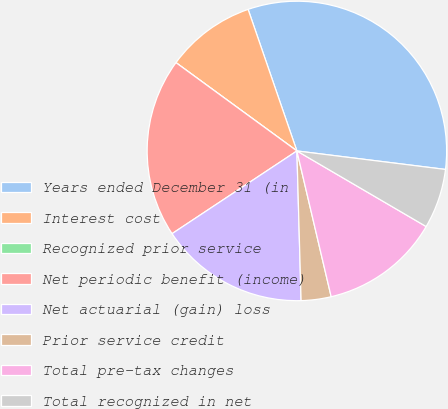Convert chart to OTSL. <chart><loc_0><loc_0><loc_500><loc_500><pie_chart><fcel>Years ended December 31 (in<fcel>Interest cost<fcel>Recognized prior service<fcel>Net periodic benefit (income)<fcel>Net actuarial (gain) loss<fcel>Prior service credit<fcel>Total pre-tax changes<fcel>Total recognized in net<nl><fcel>32.25%<fcel>9.68%<fcel>0.0%<fcel>19.35%<fcel>16.13%<fcel>3.23%<fcel>12.9%<fcel>6.45%<nl></chart> 